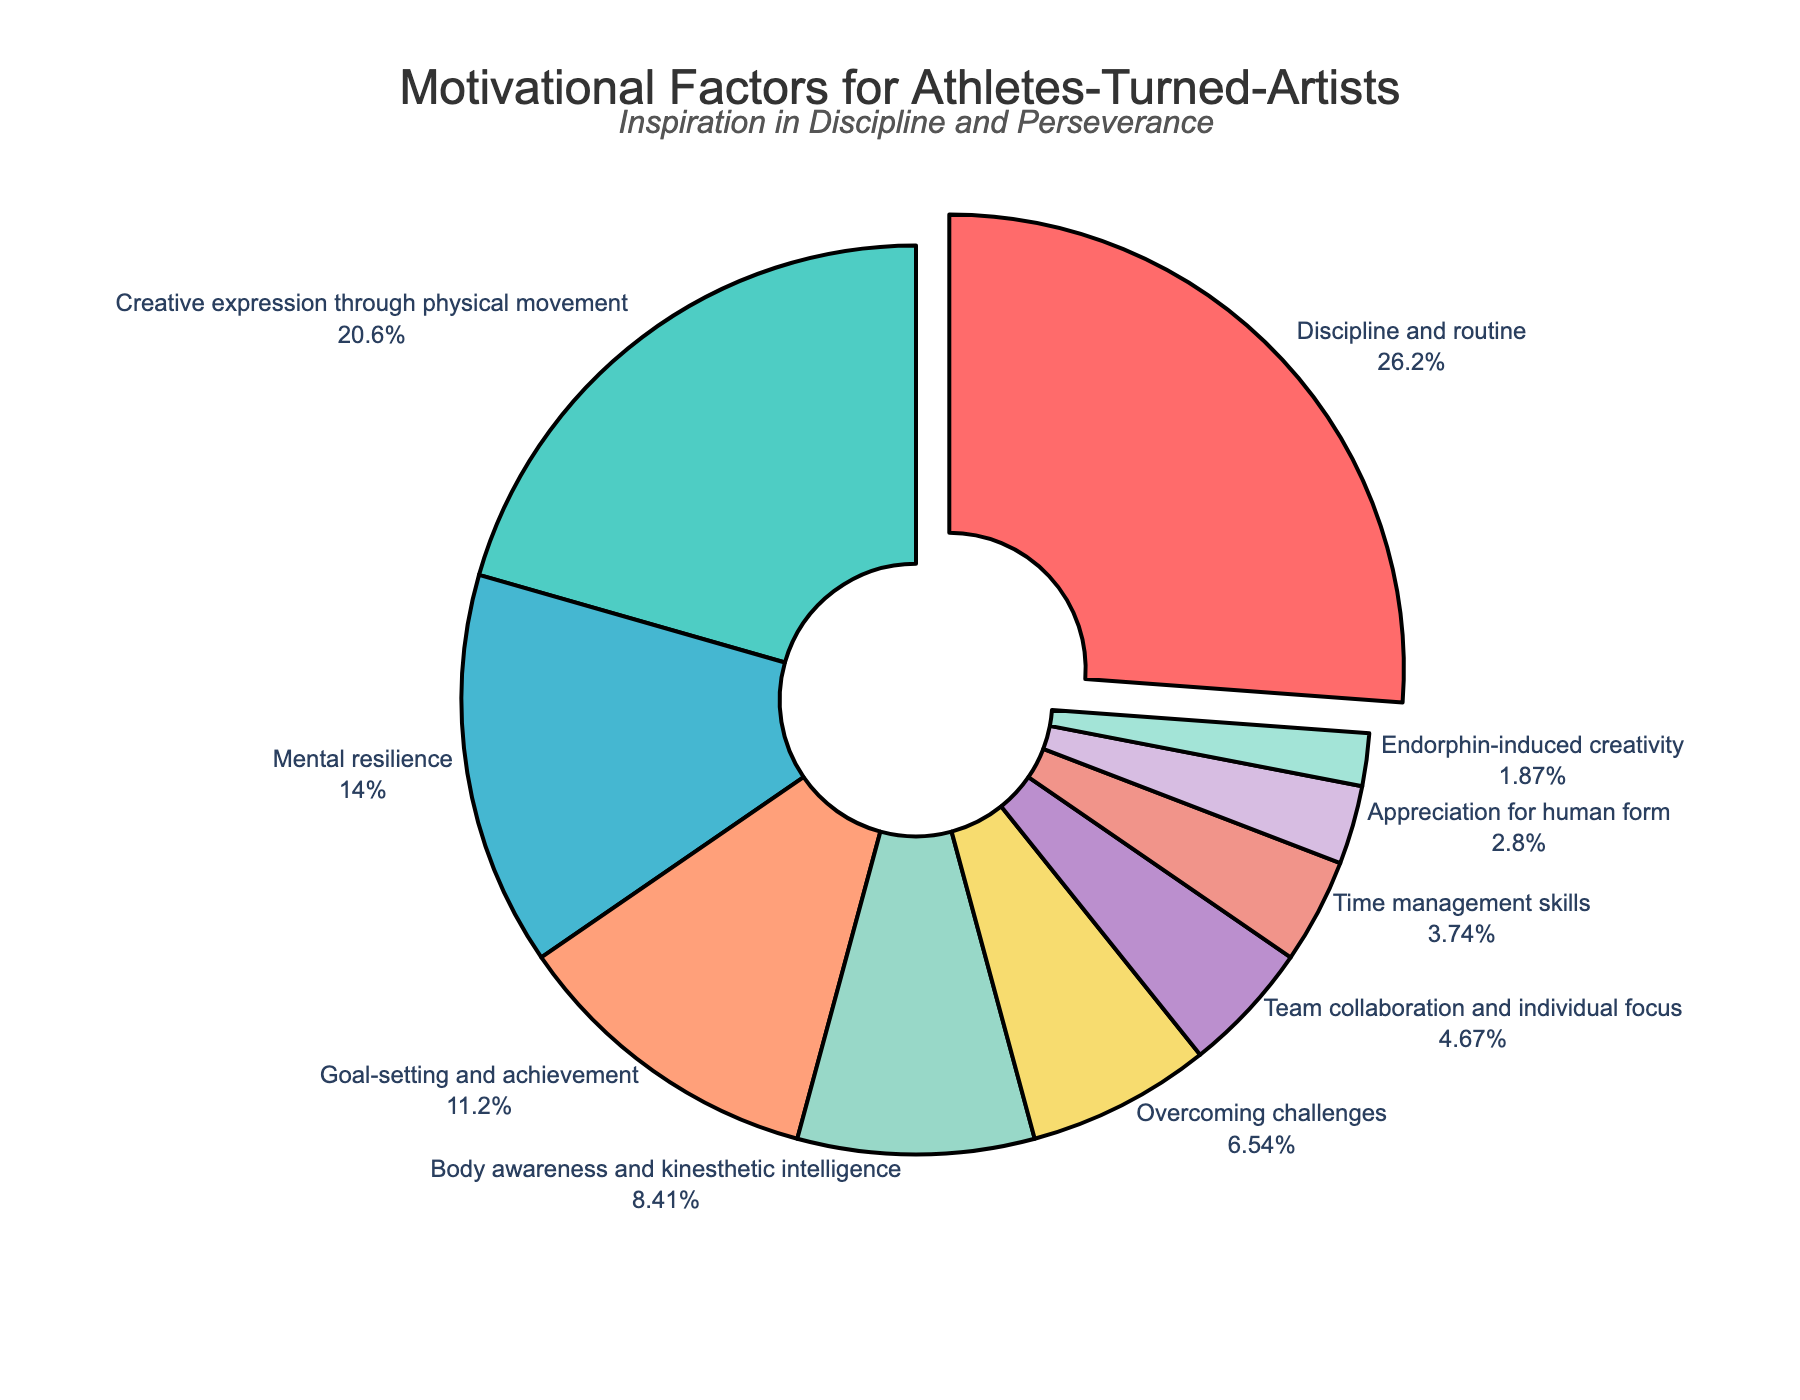What's the largest motivational factor cited by athletes-turned-artists? The largest motivational factor can be identified by looking at the slice with the highest percentage in the pie chart. From the figure, "Discipline and routine" has the highest percentage at 28%.
Answer: Discipline and routine Which motivational factors have a percentage lower than 10%? To identify these, look for slices whose percentages are less than 10%. The slices for "Body awareness and kinesthetic intelligence" (9%), "Overcoming challenges" (7%), "Team collaboration and individual focus" (5%), "Time management skills" (4%), "Appreciation for human form" (3%), and "Endorphin-induced creativity" (2%) all fall below 10%.
Answer: Body awareness and kinesthetic intelligence, Overcoming challenges, Team collaboration and individual focus, Time management skills, Appreciation for human form, Endorphin-induced creativity What is the combined percentage of "Creative expression through physical movement" and "Mental resilience"? Add the percentage values for "Creative expression through physical movement" (22%) and "Mental resilience" (15%). The sum is 22% + 15% = 37%.
Answer: 37% How many percentage points more is the "Discipline and routine" factor compared to "Goal-setting and achievement"? Subtract the percentage of "Goal-setting and achievement" (12%) from "Discipline and routine" (28%). The result is 28% - 12% = 16%.
Answer: 16% Which motivational factor is represented by the color red in the chart? The slice representing "Discipline and routine" is highlighted and colored red in the pie chart.
Answer: Discipline and routine Is "Time management skills" a more influential factor than "Appreciation for human form"? By comparing their percentages, "Time management skills" (4%) is more than "Appreciation for human form" (3%).
Answer: Yes Which motivational factors are depicted in the smallest slice of the pie chart? The smallest slices are identified by their percentages, and "Endorphin-induced creativity" has the smallest slice with 2%.
Answer: Endorphin-induced creativity 